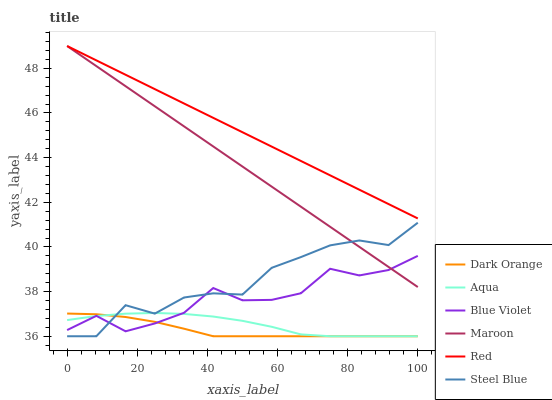Does Dark Orange have the minimum area under the curve?
Answer yes or no. Yes. Does Red have the maximum area under the curve?
Answer yes or no. Yes. Does Aqua have the minimum area under the curve?
Answer yes or no. No. Does Aqua have the maximum area under the curve?
Answer yes or no. No. Is Red the smoothest?
Answer yes or no. Yes. Is Steel Blue the roughest?
Answer yes or no. Yes. Is Aqua the smoothest?
Answer yes or no. No. Is Aqua the roughest?
Answer yes or no. No. Does Dark Orange have the lowest value?
Answer yes or no. Yes. Does Maroon have the lowest value?
Answer yes or no. No. Does Red have the highest value?
Answer yes or no. Yes. Does Aqua have the highest value?
Answer yes or no. No. Is Dark Orange less than Red?
Answer yes or no. Yes. Is Red greater than Dark Orange?
Answer yes or no. Yes. Does Maroon intersect Red?
Answer yes or no. Yes. Is Maroon less than Red?
Answer yes or no. No. Is Maroon greater than Red?
Answer yes or no. No. Does Dark Orange intersect Red?
Answer yes or no. No. 